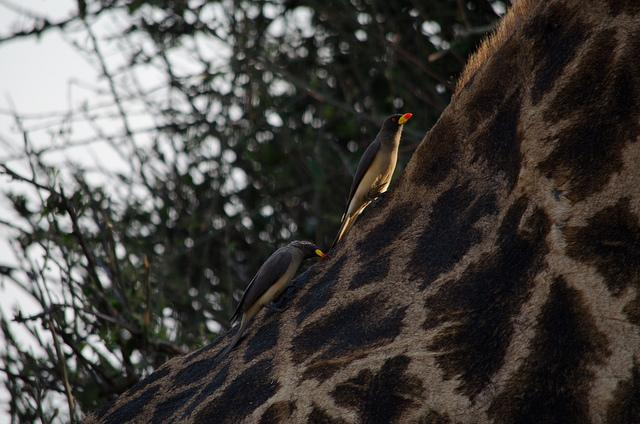Where are the birds standing on? Please explain your reasoning. giraffe. The colour and pattern of the animal they are standing on can clearly be identified as a giraffe. 